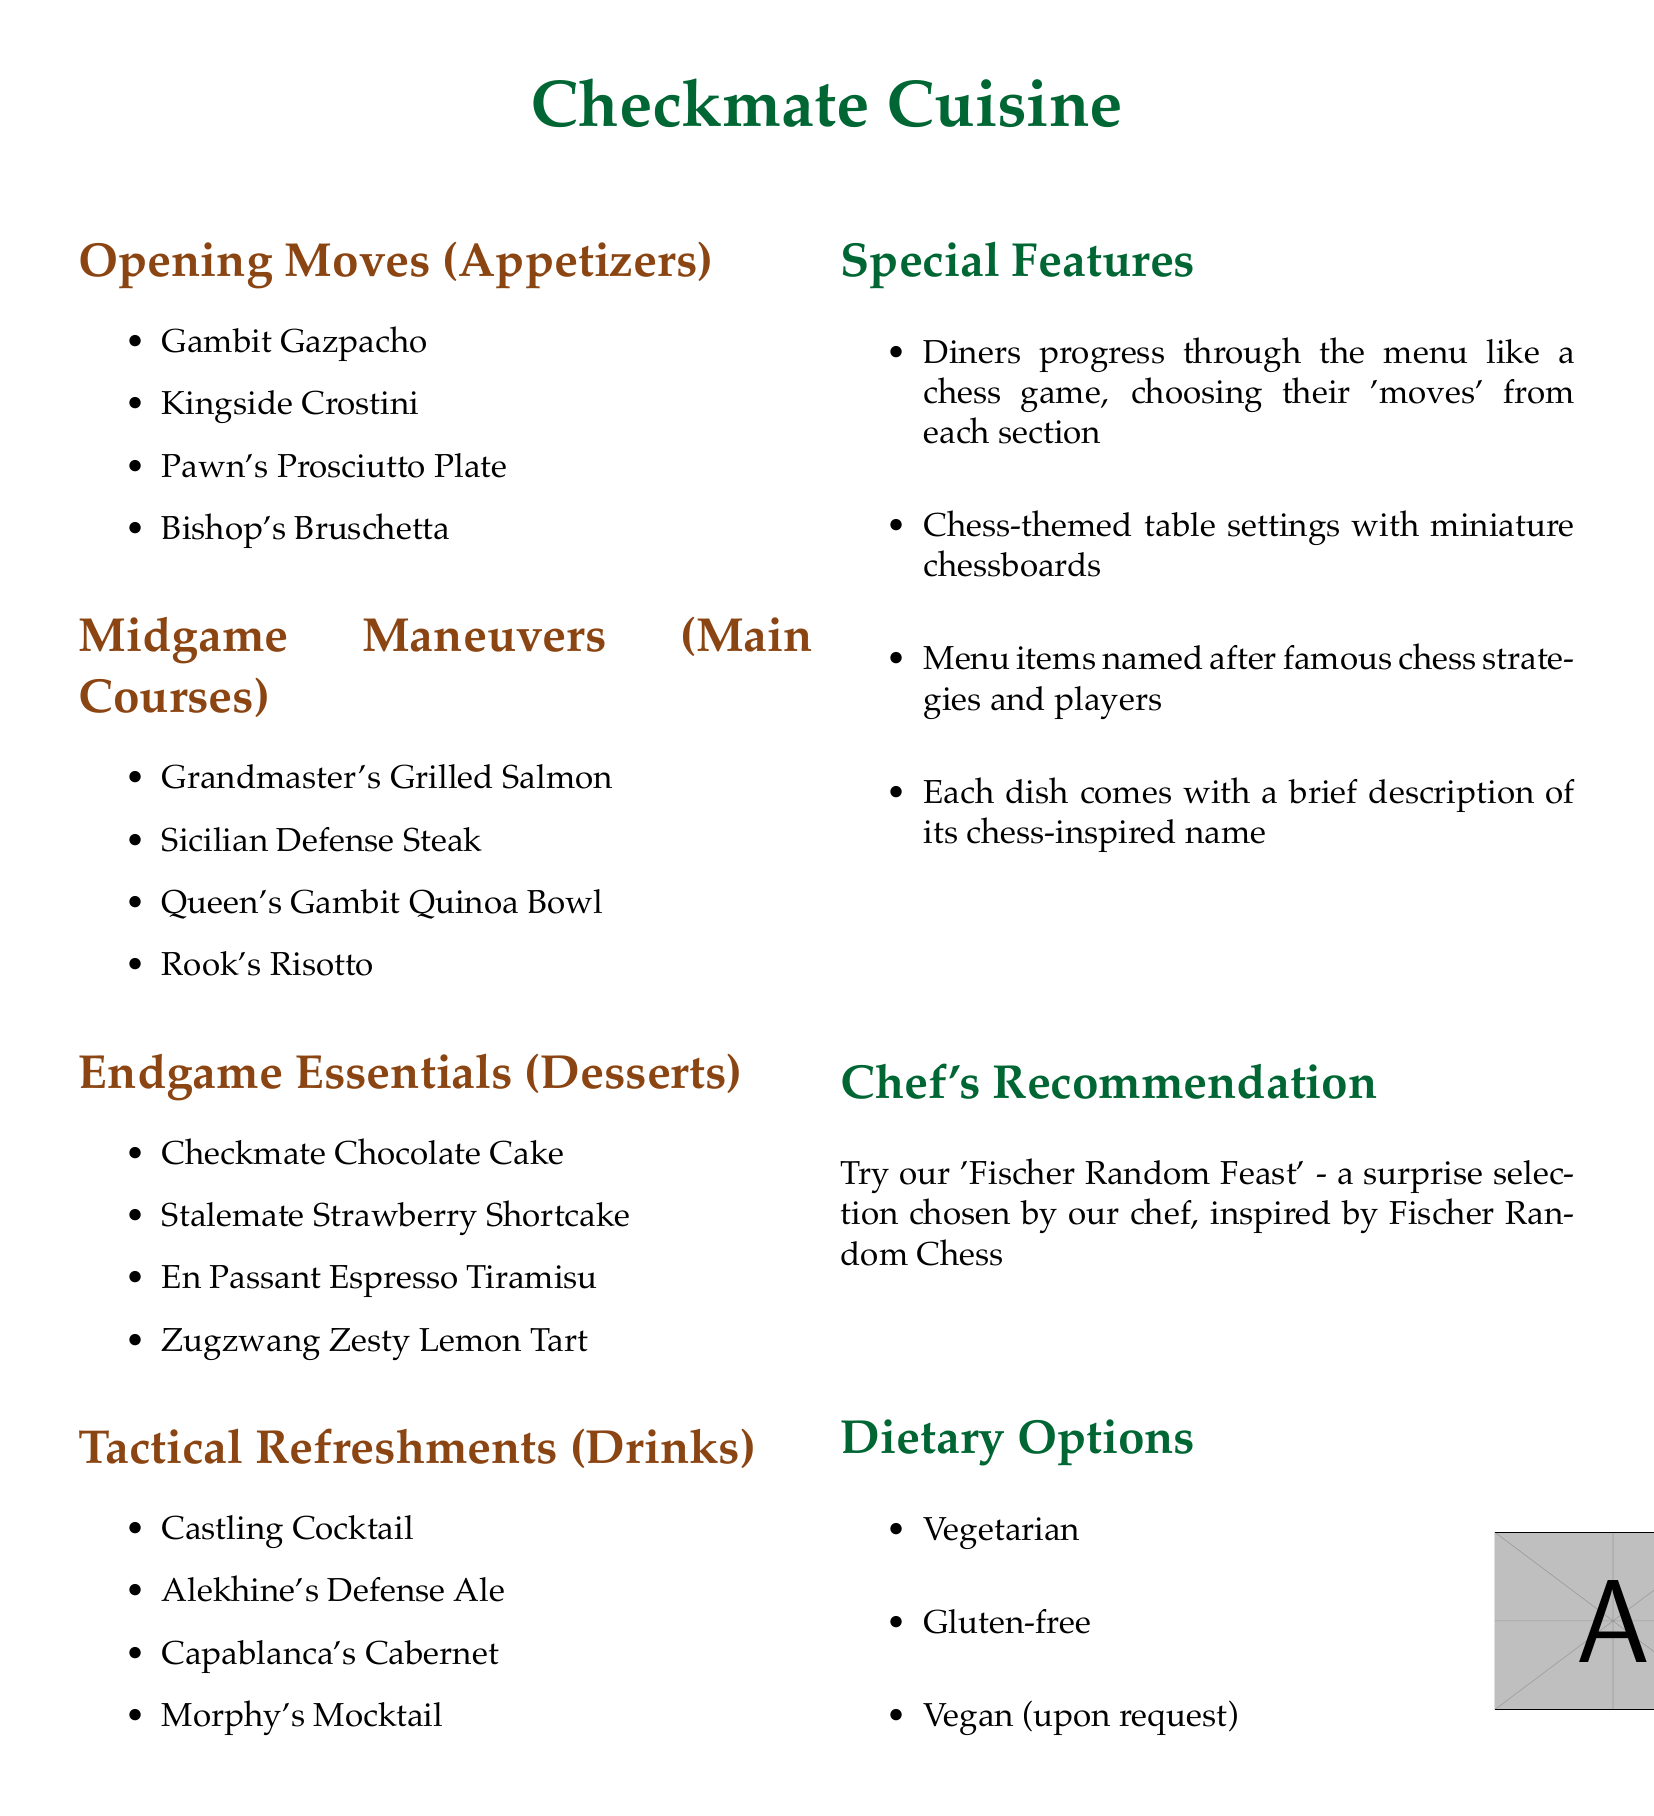What are the appetizers called? The section is titled "Opening Moves" which lists the appetizers with names like "Gambit Gazpacho" and "Kingside Crostini".
Answer: Opening Moves How many desserts are listed? The "Endgame Essentials" section includes four dessert options: "Checkmate Chocolate Cake", "Stalemate Strawberry Shortcake", "En Passant Espresso Tiramisu", and "Zugzwang Zesty Lemon Tart".
Answer: 4 What is the chef's recommendation? The section for recommendations suggests trying the "Fischer Random Feast," which is inspired by Fischer Random Chess.
Answer: Fischer Random Feast What dietary options are available? The document lists options under "Dietary Options," including vegetarian, gluten-free, and vegan (upon request).
Answer: Vegetarian, Gluten-free, Vegan Which drink is named after a famous chess player? The "Tactical Refreshments" section includes several drinks, one of which is "Alekhine's Defense Ale," named after a famous chess player.
Answer: Alekhine's Defense Ale What is the theme of the menu? The menu features a chess theme, with items named after chess strategies and players, and diners progress through the menu like a chess game.
Answer: Chess theme How is the table setting described? The "Special Features" section mentions chess-themed table settings with miniature chessboards.
Answer: Chess-themed table settings What is the color of the chef’s recommendation section? The section for recommendations is highlighted in the color green as indicated in the document layout.
Answer: Green 